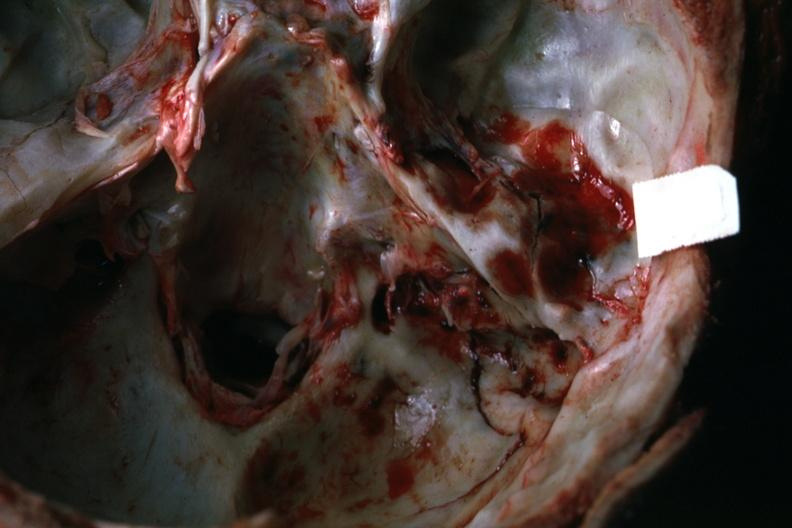does this image show view of petrous portion temporal bone rather close-up 22yo man 37 foot fall?
Answer the question using a single word or phrase. Yes 